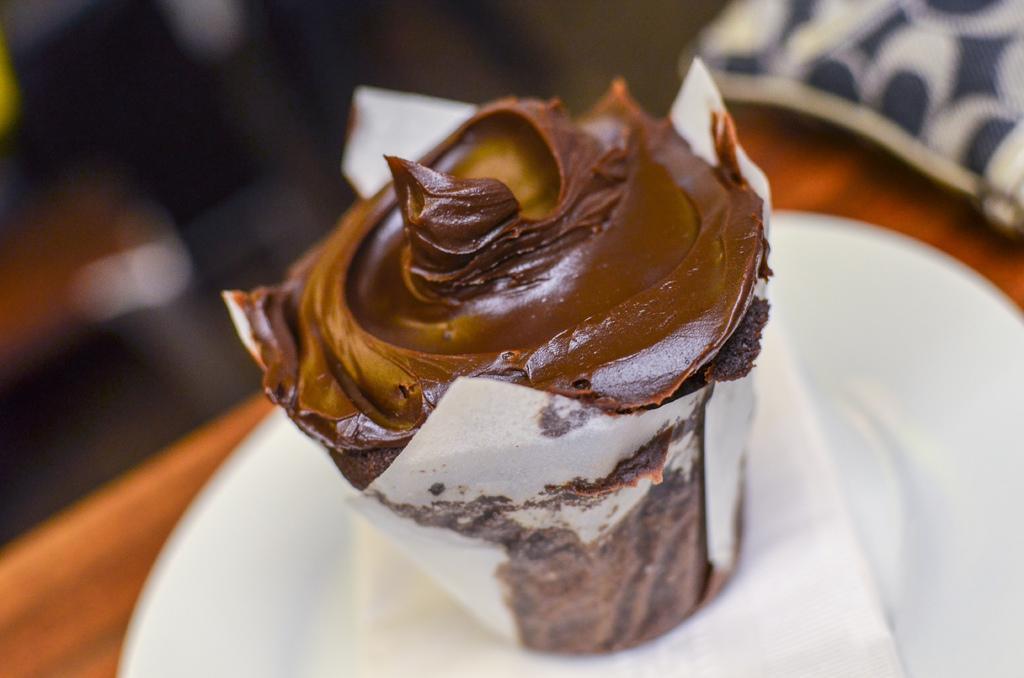Describe this image in one or two sentences. In this image, I can see a cupcake and a tissue paper in the plate. There is a blurred background. 